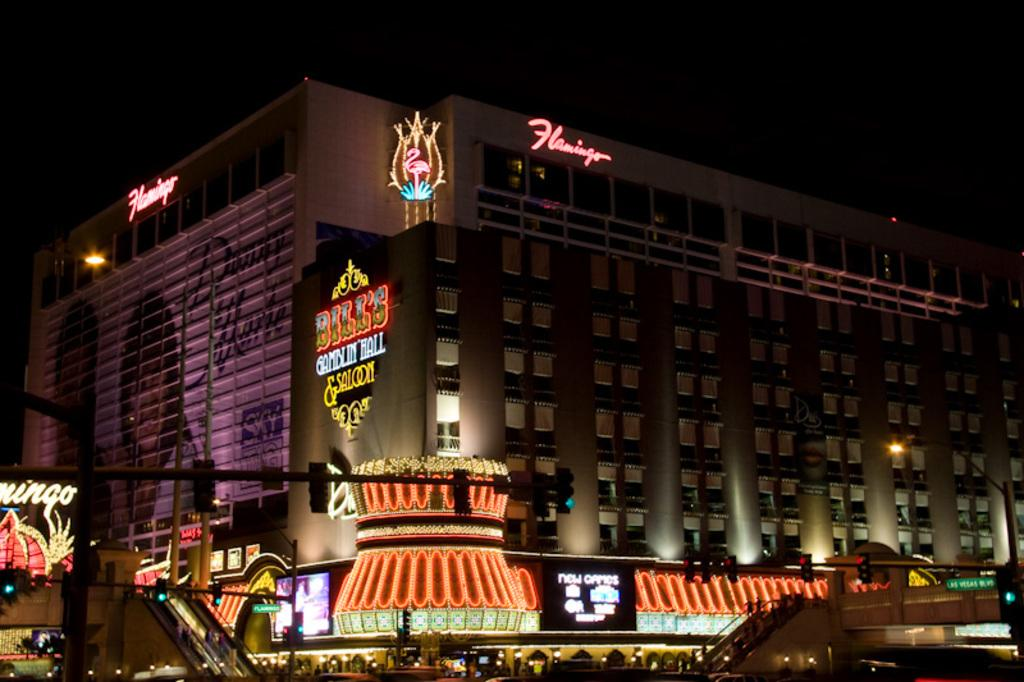What time of day was the image taken? The image was taken at night. What can be seen in the background of the image? There is a building with lights in the background. What is the appearance of the stores and buildings in the front? The stores and buildings in the front have colorful lights. How does the digestion process of the cakes in the image appear to be going? There are no cakes present in the image, so it is not possible to determine how their digestion process might be going. 